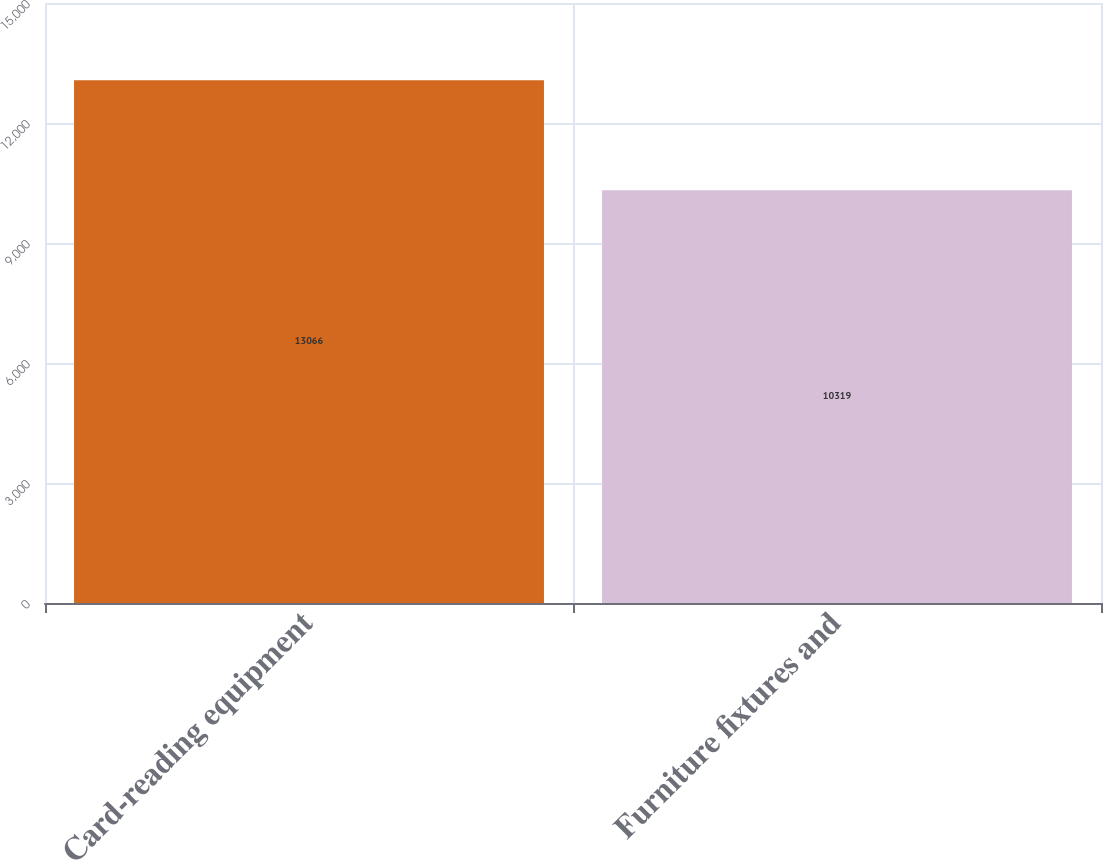Convert chart to OTSL. <chart><loc_0><loc_0><loc_500><loc_500><bar_chart><fcel>Card-reading equipment<fcel>Furniture fixtures and<nl><fcel>13066<fcel>10319<nl></chart> 